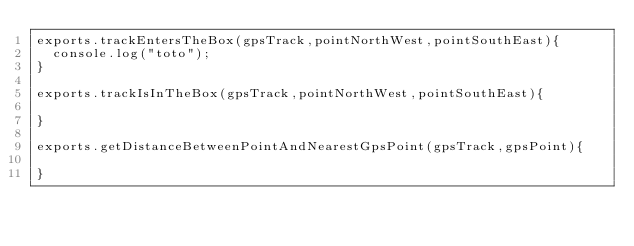<code> <loc_0><loc_0><loc_500><loc_500><_JavaScript_>exports.trackEntersTheBox(gpsTrack,pointNorthWest,pointSouthEast){
  console.log("toto");
}

exports.trackIsInTheBox(gpsTrack,pointNorthWest,pointSouthEast){

}

exports.getDistanceBetweenPointAndNearestGpsPoint(gpsTrack,gpsPoint){

}
</code> 